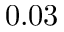Convert formula to latex. <formula><loc_0><loc_0><loc_500><loc_500>0 . 0 3</formula> 